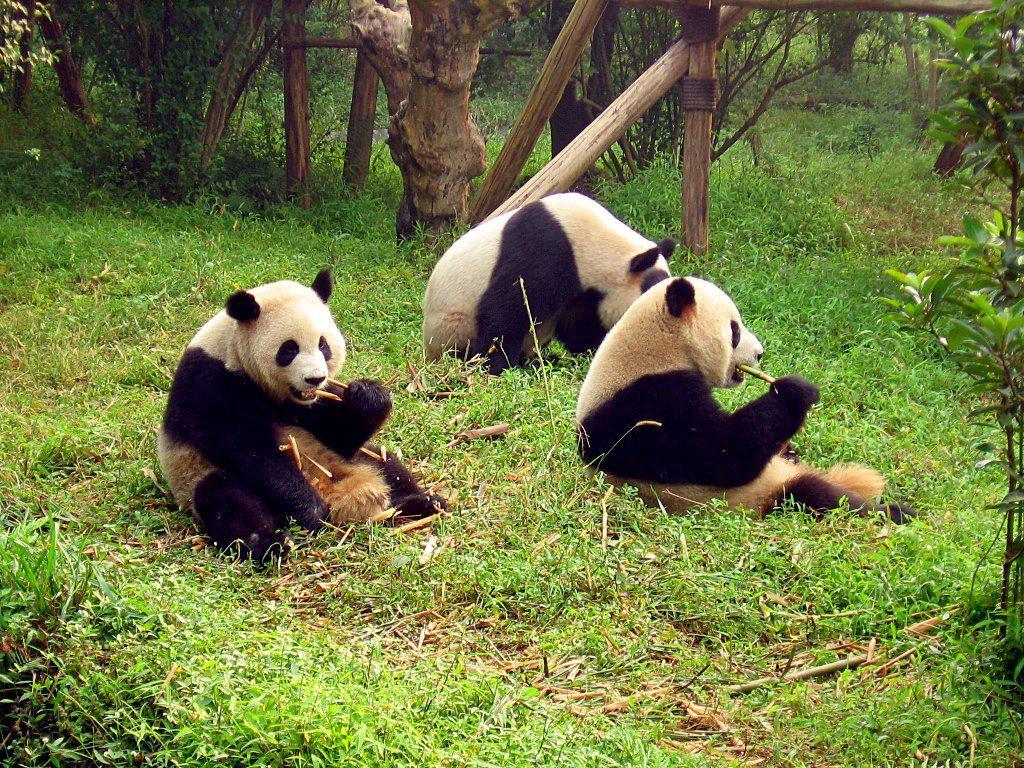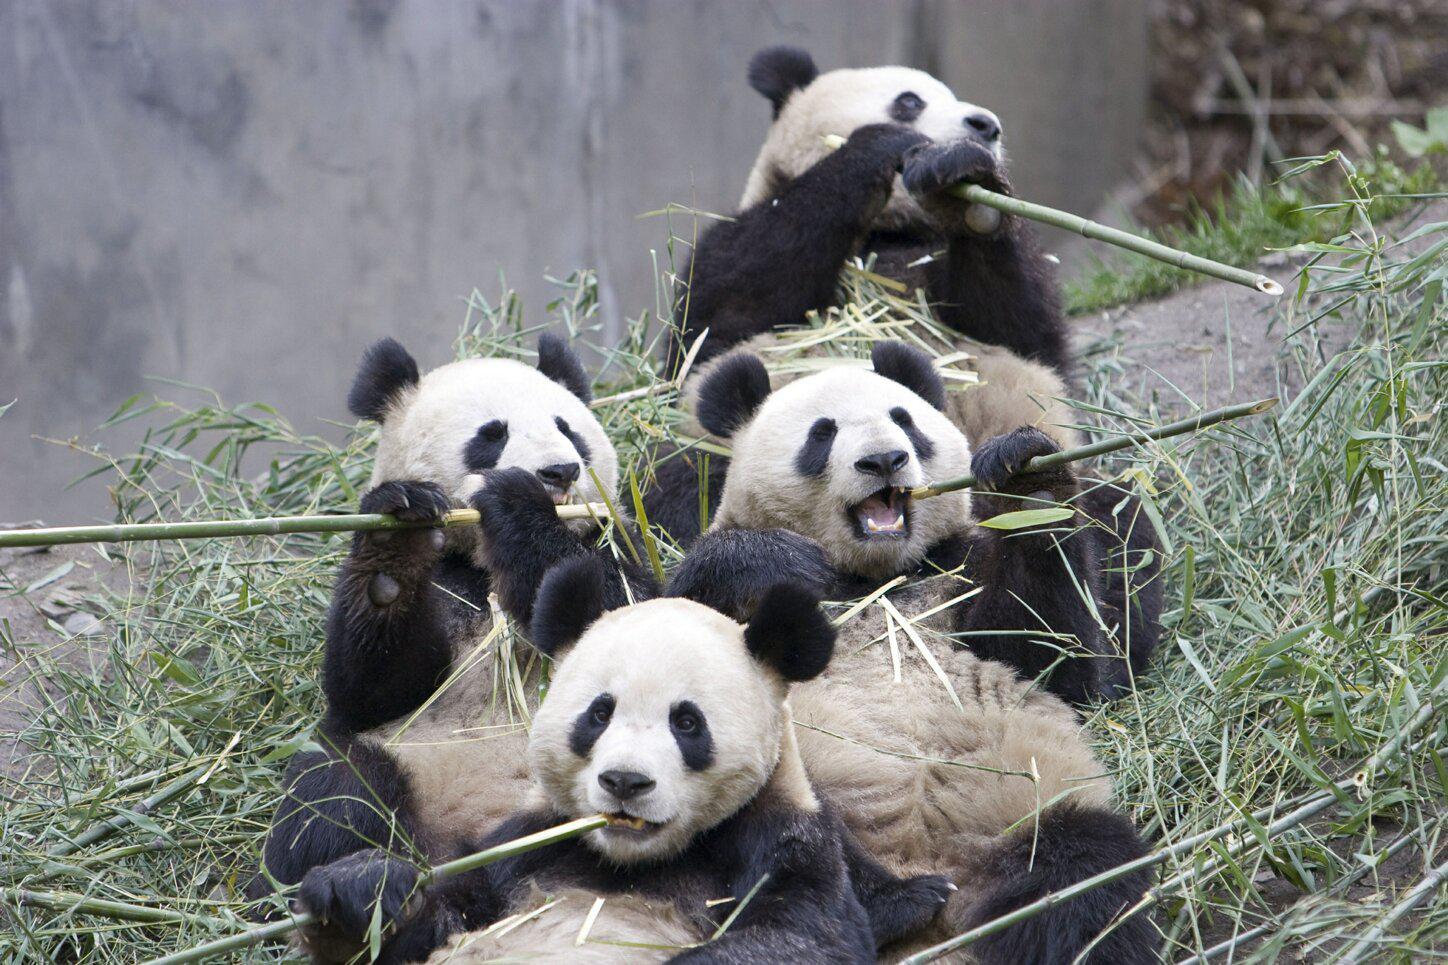The first image is the image on the left, the second image is the image on the right. Analyze the images presented: Is the assertion "One image shows multiple pandas sitting in a group chewing on stalks, and the other includes a panda with its arms flung wide." valid? Answer yes or no. No. The first image is the image on the left, the second image is the image on the right. Examine the images to the left and right. Is the description "There are at most 5 pandas in the image pair." accurate? Answer yes or no. No. 